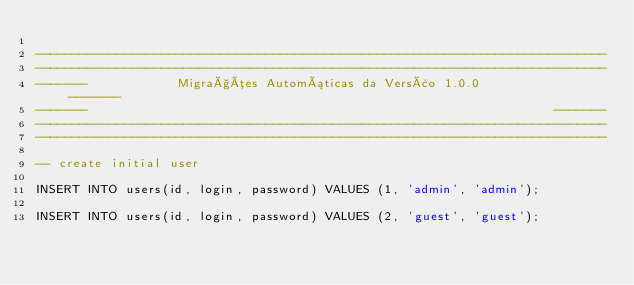<code> <loc_0><loc_0><loc_500><loc_500><_SQL_>
-----------------------------------------------------------------------------
-----------------------------------------------------------------------------
-------            Migrações Automáticas da Versão 1.0.0              -------
-------                                                               -------
-----------------------------------------------------------------------------
-----------------------------------------------------------------------------

-- create initial user

INSERT INTO users(id, login, password) VALUES (1, 'admin', 'admin');

INSERT INTO users(id, login, password) VALUES (2, 'guest', 'guest');

</code> 